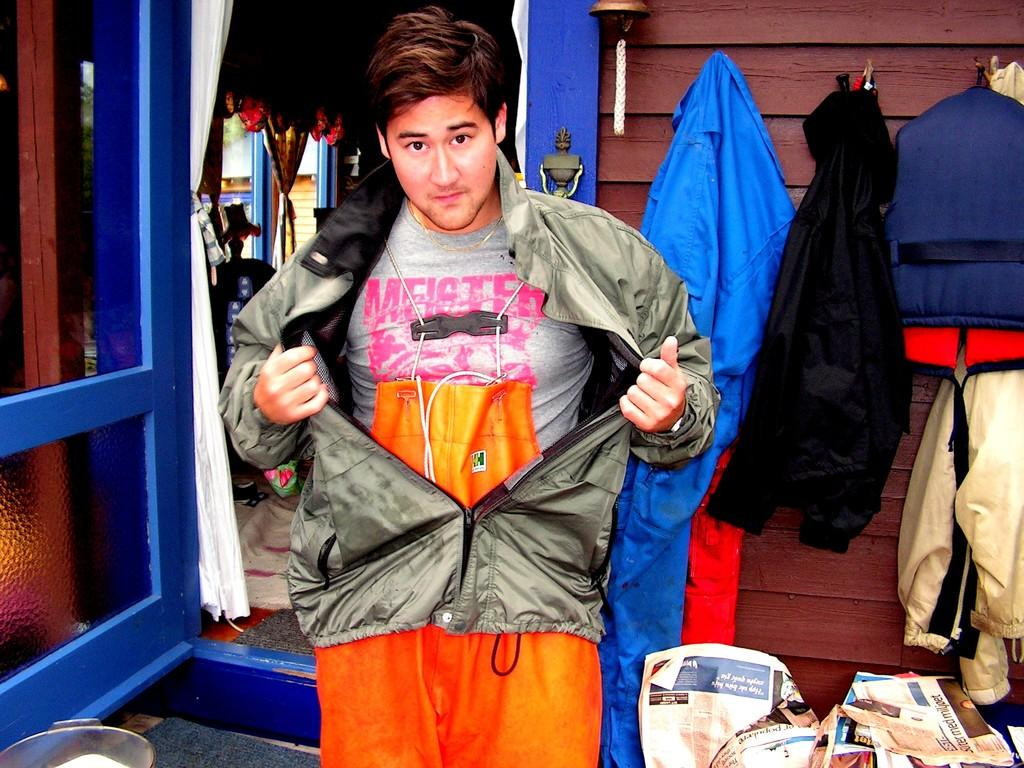What items are in the middle of the image? There is a jacket and a t-shirt in the middle of the image. What can be seen in the background of the image? In the background of the image, there are jackets, newspapers, a house, curtains, a door, windows, and a bell. What type of structure is visible in the background? There is a wall visible in the background of the image. Can you tell me how many cows are visible in the image? There are no cows present in the image. What type of fuel is being used by the zoo animals in the image? There is no zoo or animals present in the image, so it is not possible to determine what type of fuel they might be using. 